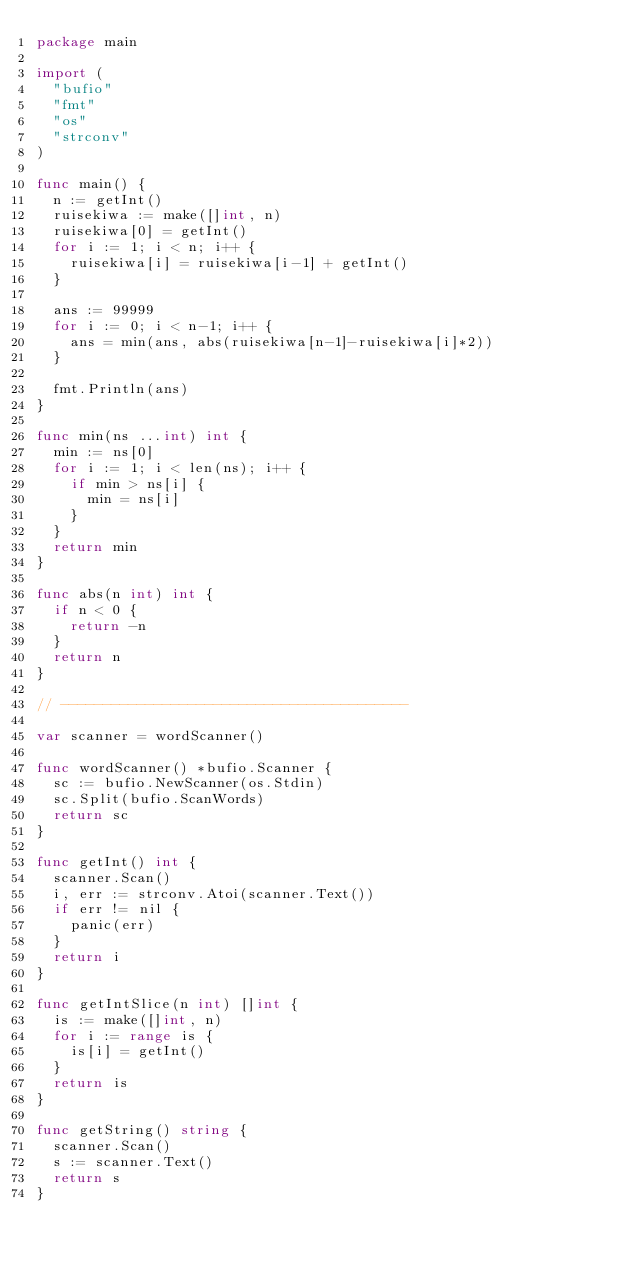<code> <loc_0><loc_0><loc_500><loc_500><_Go_>package main

import (
	"bufio"
	"fmt"
	"os"
	"strconv"
)

func main() {
	n := getInt()
	ruisekiwa := make([]int, n)
	ruisekiwa[0] = getInt()
	for i := 1; i < n; i++ {
		ruisekiwa[i] = ruisekiwa[i-1] + getInt()
	}

	ans := 99999
	for i := 0; i < n-1; i++ {
		ans = min(ans, abs(ruisekiwa[n-1]-ruisekiwa[i]*2))
	}

	fmt.Println(ans)
}

func min(ns ...int) int {
	min := ns[0]
	for i := 1; i < len(ns); i++ {
		if min > ns[i] {
			min = ns[i]
		}
	}
	return min
}

func abs(n int) int {
	if n < 0 {
		return -n
	}
	return n
}

// -----------------------------------------

var scanner = wordScanner()

func wordScanner() *bufio.Scanner {
	sc := bufio.NewScanner(os.Stdin)
	sc.Split(bufio.ScanWords)
	return sc
}

func getInt() int {
	scanner.Scan()
	i, err := strconv.Atoi(scanner.Text())
	if err != nil {
		panic(err)
	}
	return i
}

func getIntSlice(n int) []int {
	is := make([]int, n)
	for i := range is {
		is[i] = getInt()
	}
	return is
}

func getString() string {
	scanner.Scan()
	s := scanner.Text()
	return s
}
</code> 